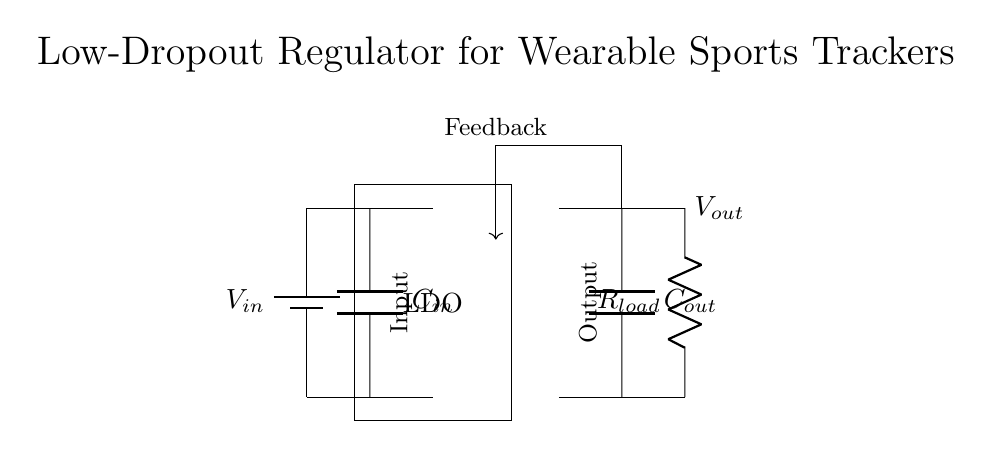What is the input voltage for the regulator? The input voltage (V_in) is provided by the battery at the beginning of the circuit.
Answer: V_in What is the function of the LDO? The LDO, or Low-Dropout Regulator, is used to maintain a stable output voltage (V_out) even when the input voltage (V_in) is slightly above V_out.
Answer: Maintain stable voltage What component smooths the input voltage? The input capacitor (C_in) is responsible for smoothing the input voltage by filtering out any fluctuations.
Answer: C_in How many capacitors are present in this circuit? There are two capacitors: C_in and C_out, one for the input and one for the output, respectively.
Answer: Two What does the feedback path do in this circuit? The feedback path compares the output voltage (V_out) to the desired voltage level, allowing the regulator to adjust its output to maintain the target value.
Answer: Adjust output voltage What type of load is connected to the output of the LDO? The load is represented by a resistor (R_load), which indicates that the output is connected to a resistive load.
Answer: Resistor What is the purpose of the output capacitor? The output capacitor (C_out) stabilizes the output voltage and reduces any voltage ripple caused by changes in the load current.
Answer: Stabilize output voltage 